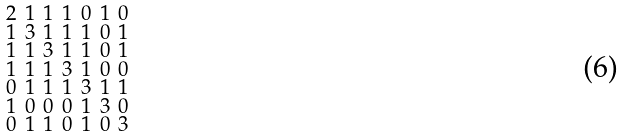<formula> <loc_0><loc_0><loc_500><loc_500>\begin{smallmatrix} 2 & 1 & 1 & 1 & 0 & 1 & 0 \\ 1 & 3 & 1 & 1 & 1 & 0 & 1 \\ 1 & 1 & 3 & 1 & 1 & 0 & 1 \\ 1 & 1 & 1 & 3 & 1 & 0 & 0 \\ 0 & 1 & 1 & 1 & 3 & 1 & 1 \\ 1 & 0 & 0 & 0 & 1 & 3 & 0 \\ 0 & 1 & 1 & 0 & 1 & 0 & 3 \end{smallmatrix}</formula> 